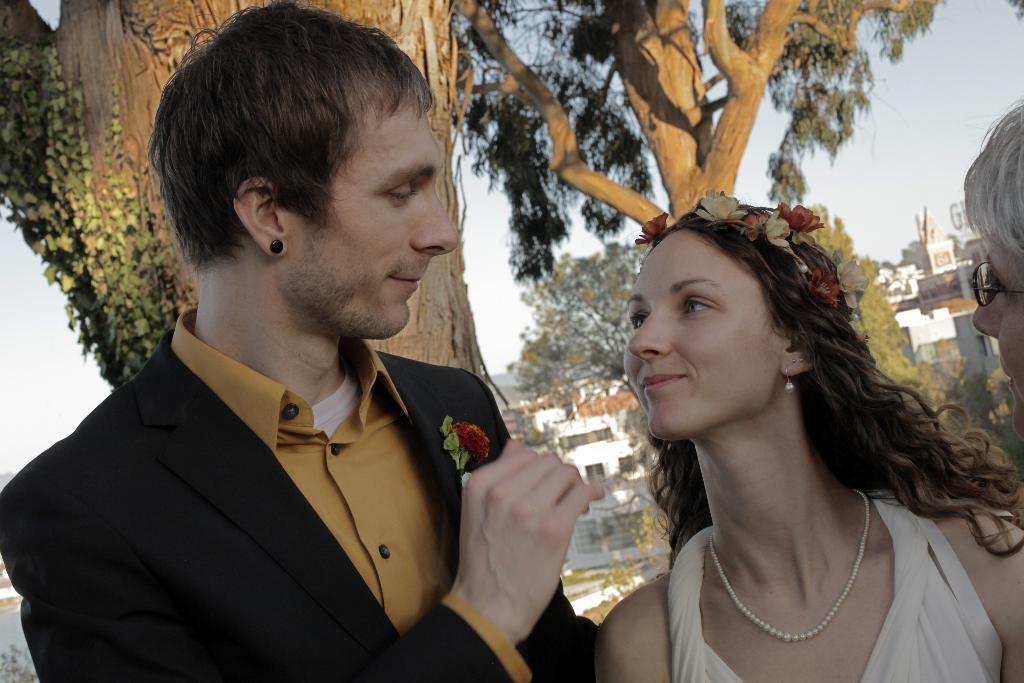In one or two sentences, can you explain what this image depicts? In this image there is a couple in the middle. There is a man on the left side and a woman on the right side is having a flower wreath. In the background there are trees and buildings. 